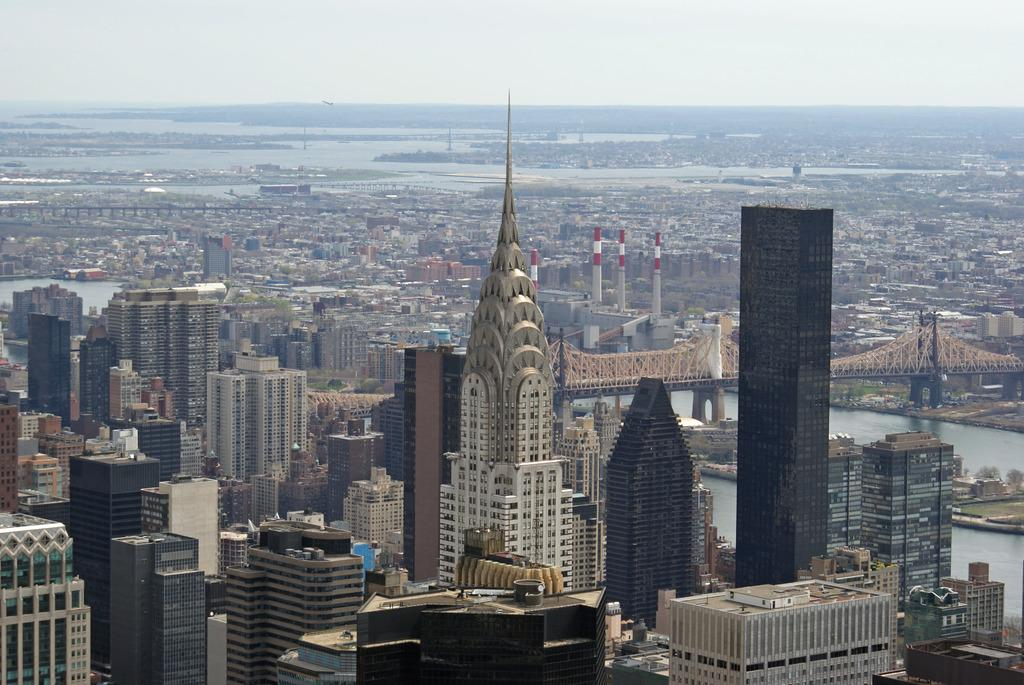What is the main subject of the image? The image provides an overview of a city. Can you identify any specific structures or landmarks in the image? Yes, there is a bridge on the right side of the image. What natural feature is visible at the bottom right side of the image? There is a sea at the bottom right side of the image. What type of muscle can be seen flexing in the image? There is no muscle visible in the image; it is a city overview with a bridge and a sea. 